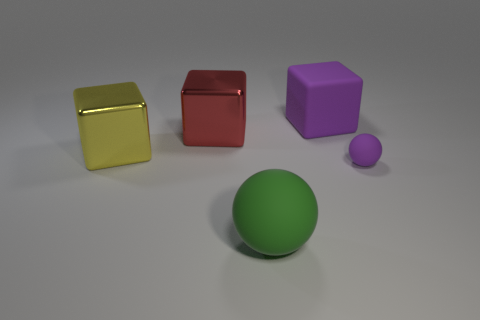Is there anything else that has the same size as the purple ball?
Offer a very short reply. No. Does the purple matte thing that is in front of the yellow block have the same size as the matte cube?
Your answer should be very brief. No. What number of matte things are either big yellow balls or yellow objects?
Ensure brevity in your answer.  0. What number of cubes are left of the sphere that is to the left of the small purple object?
Offer a terse response. 2. What shape is the thing that is both in front of the large yellow cube and to the left of the large purple cube?
Ensure brevity in your answer.  Sphere. There is a ball to the right of the large rubber object that is on the left side of the purple matte thing that is behind the red thing; what is its material?
Your response must be concise. Rubber. The thing that is the same color as the rubber block is what size?
Offer a terse response. Small. What is the material of the green thing?
Provide a short and direct response. Rubber. Are the tiny purple ball and the yellow thing that is behind the tiny object made of the same material?
Your response must be concise. No. The large shiny block that is in front of the metallic object that is behind the large yellow metal cube is what color?
Your response must be concise. Yellow. 